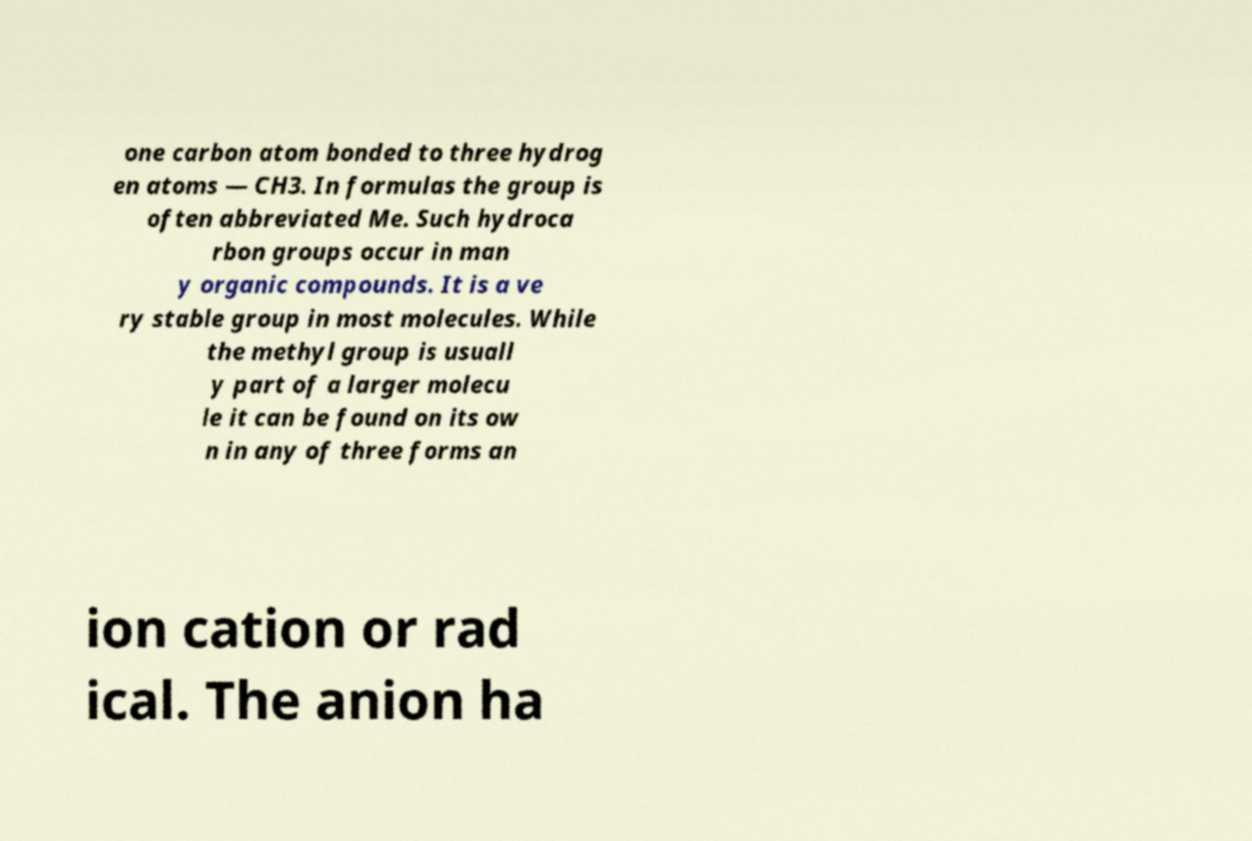Could you assist in decoding the text presented in this image and type it out clearly? one carbon atom bonded to three hydrog en atoms — CH3. In formulas the group is often abbreviated Me. Such hydroca rbon groups occur in man y organic compounds. It is a ve ry stable group in most molecules. While the methyl group is usuall y part of a larger molecu le it can be found on its ow n in any of three forms an ion cation or rad ical. The anion ha 